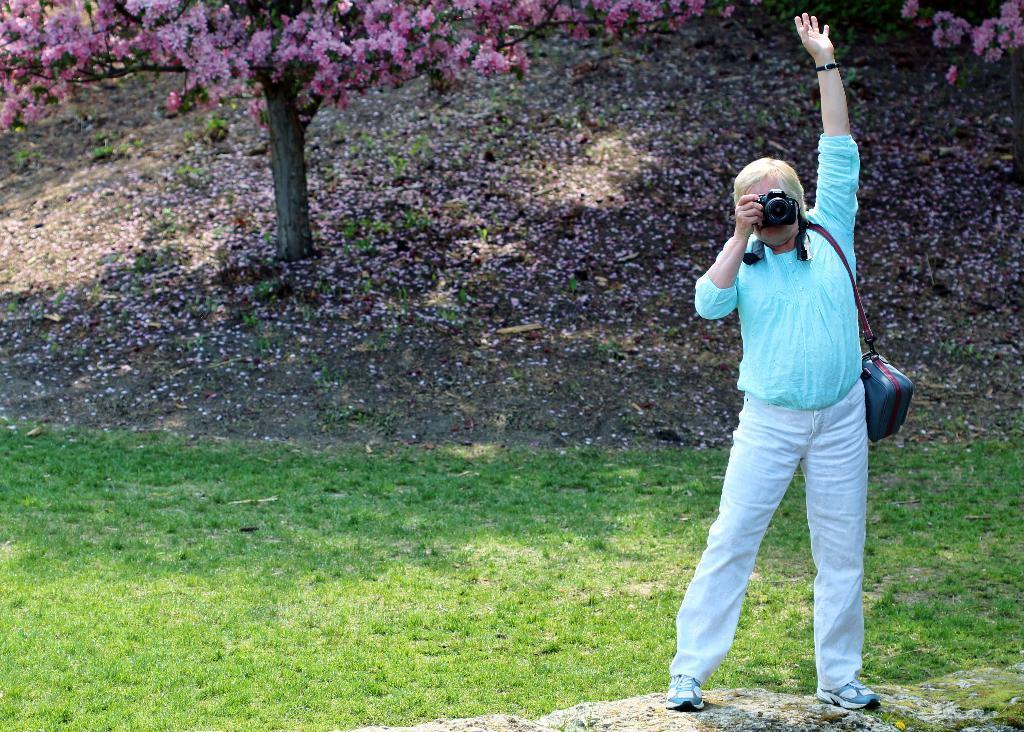Can you describe this image briefly? In this image in the front there is a person standing and holding a camera and clicking a photo and there is a bag with the person. In the center there is grass on the ground. In the background there are flowers. 